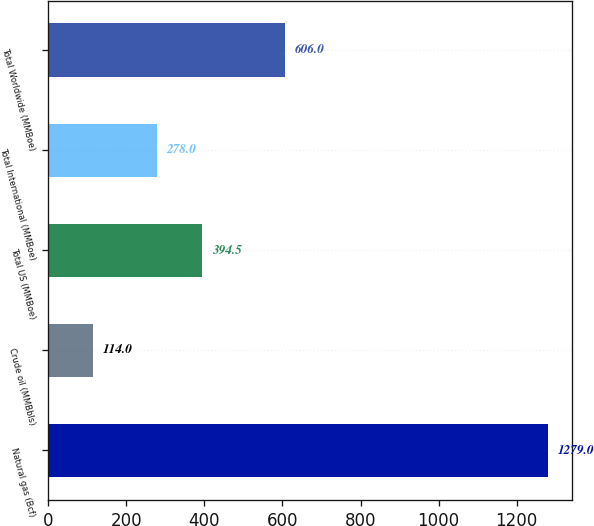Convert chart to OTSL. <chart><loc_0><loc_0><loc_500><loc_500><bar_chart><fcel>Natural gas (Bcf)<fcel>Crude oil (MMBbls)<fcel>Total US (MMBoe)<fcel>Total International (MMBoe)<fcel>Total Worldwide (MMBoe)<nl><fcel>1279<fcel>114<fcel>394.5<fcel>278<fcel>606<nl></chart> 